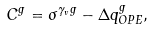<formula> <loc_0><loc_0><loc_500><loc_500>C ^ { g } = \sigma ^ { \gamma _ { v } g } - \Delta q ^ { g } _ { O P E } ,</formula> 